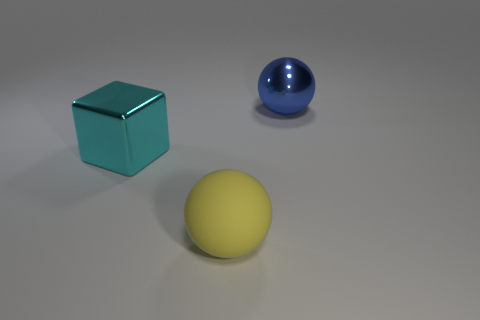Add 3 big cubes. How many objects exist? 6 Subtract all blocks. How many objects are left? 2 Subtract 0 cyan cylinders. How many objects are left? 3 Subtract all small cyan rubber blocks. Subtract all large blue things. How many objects are left? 2 Add 3 big matte objects. How many big matte objects are left? 4 Add 1 gray blocks. How many gray blocks exist? 1 